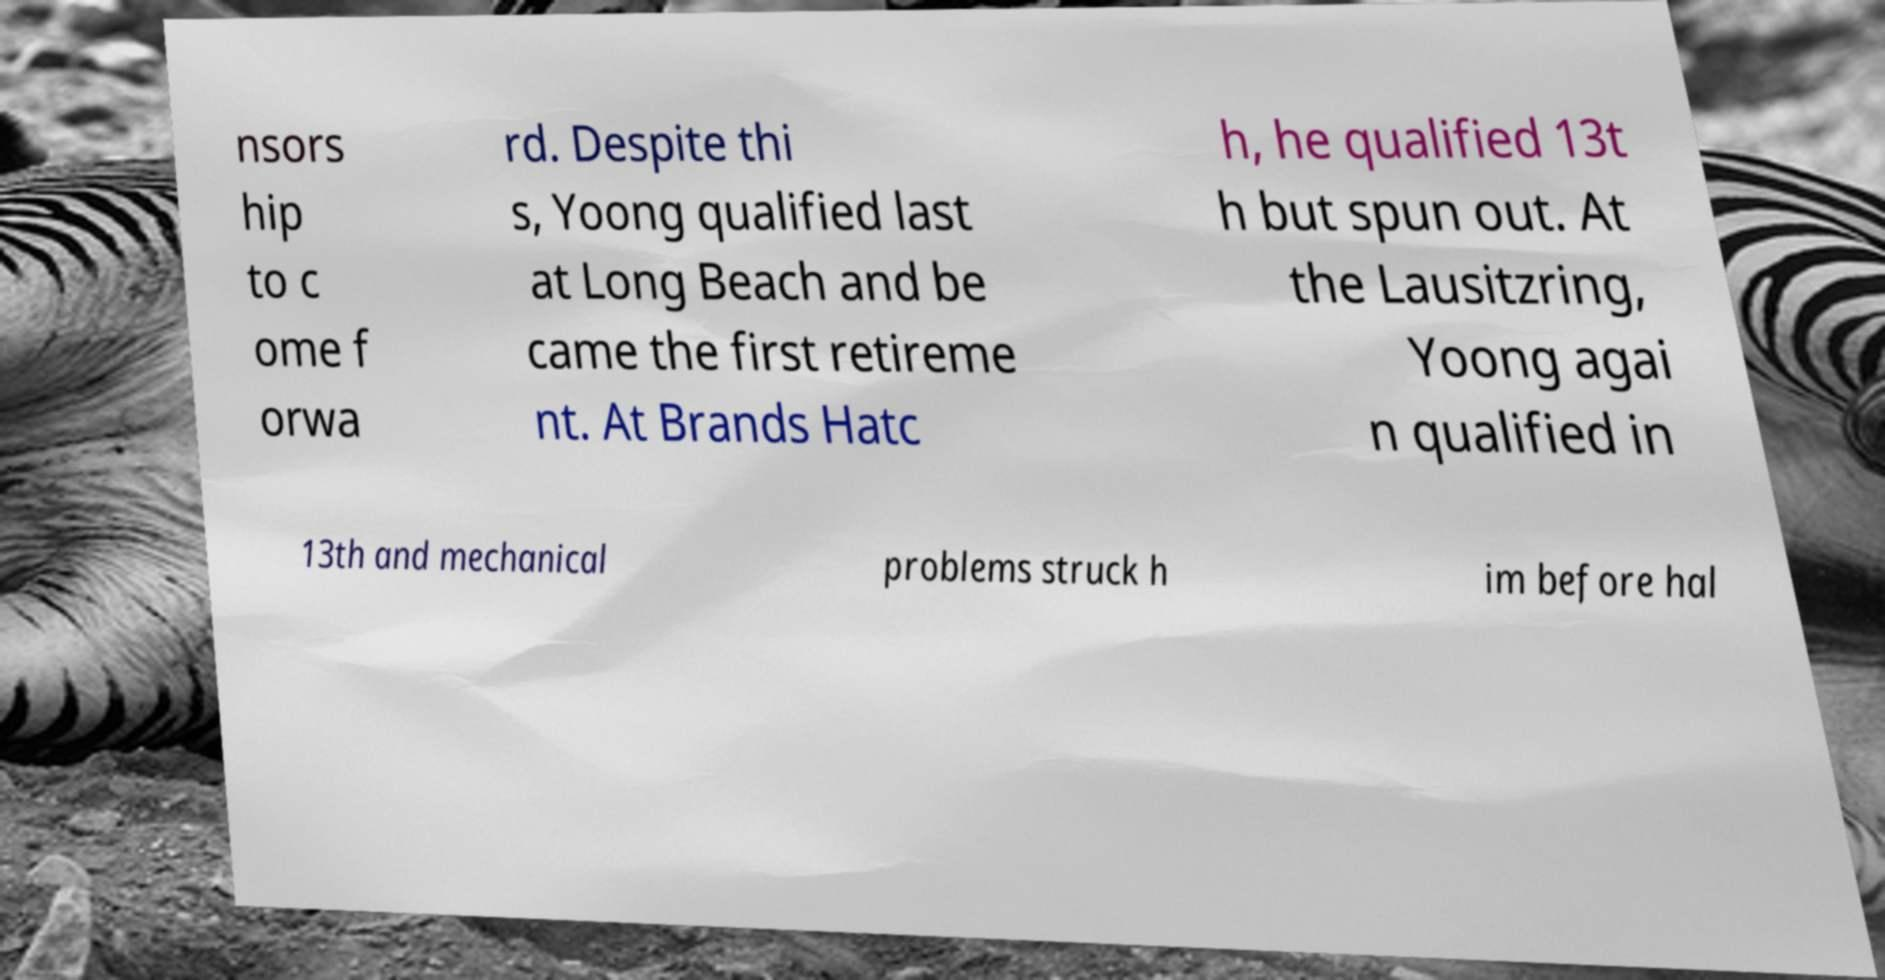What messages or text are displayed in this image? I need them in a readable, typed format. nsors hip to c ome f orwa rd. Despite thi s, Yoong qualified last at Long Beach and be came the first retireme nt. At Brands Hatc h, he qualified 13t h but spun out. At the Lausitzring, Yoong agai n qualified in 13th and mechanical problems struck h im before hal 